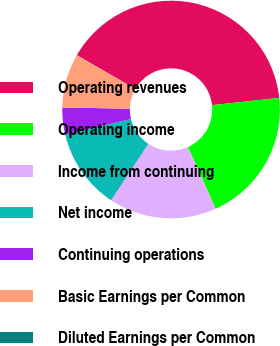<chart> <loc_0><loc_0><loc_500><loc_500><pie_chart><fcel>Operating revenues<fcel>Operating income<fcel>Income from continuing<fcel>Net income<fcel>Continuing operations<fcel>Basic Earnings per Common<fcel>Diluted Earnings per Common<nl><fcel>39.98%<fcel>19.99%<fcel>16.0%<fcel>12.0%<fcel>4.01%<fcel>8.01%<fcel>0.01%<nl></chart> 